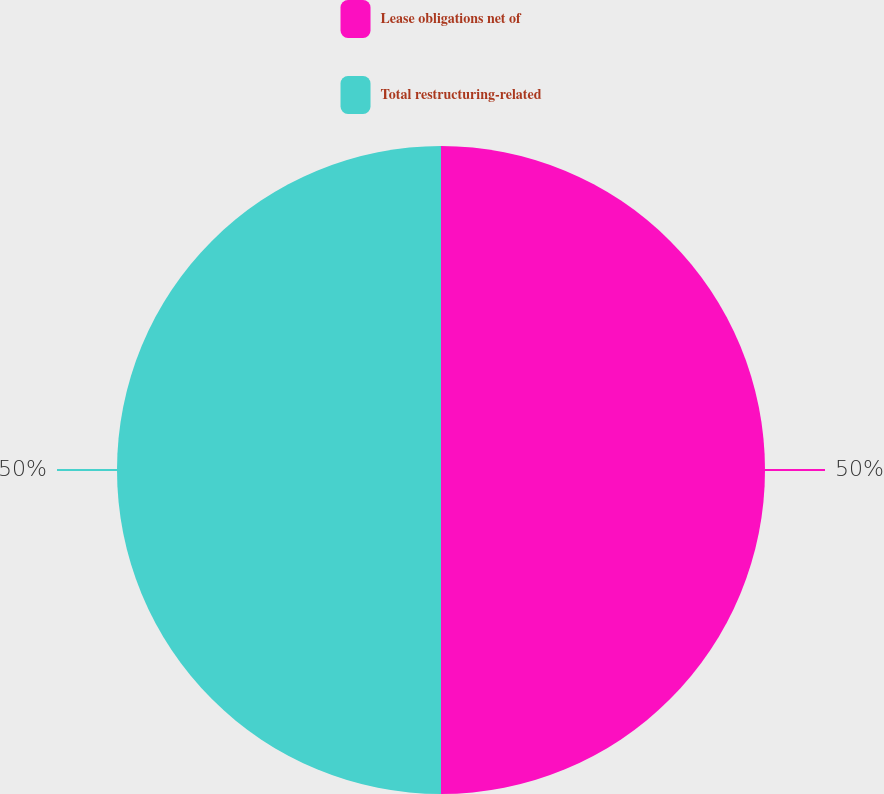<chart> <loc_0><loc_0><loc_500><loc_500><pie_chart><fcel>Lease obligations net of<fcel>Total restructuring-related<nl><fcel>50.0%<fcel>50.0%<nl></chart> 